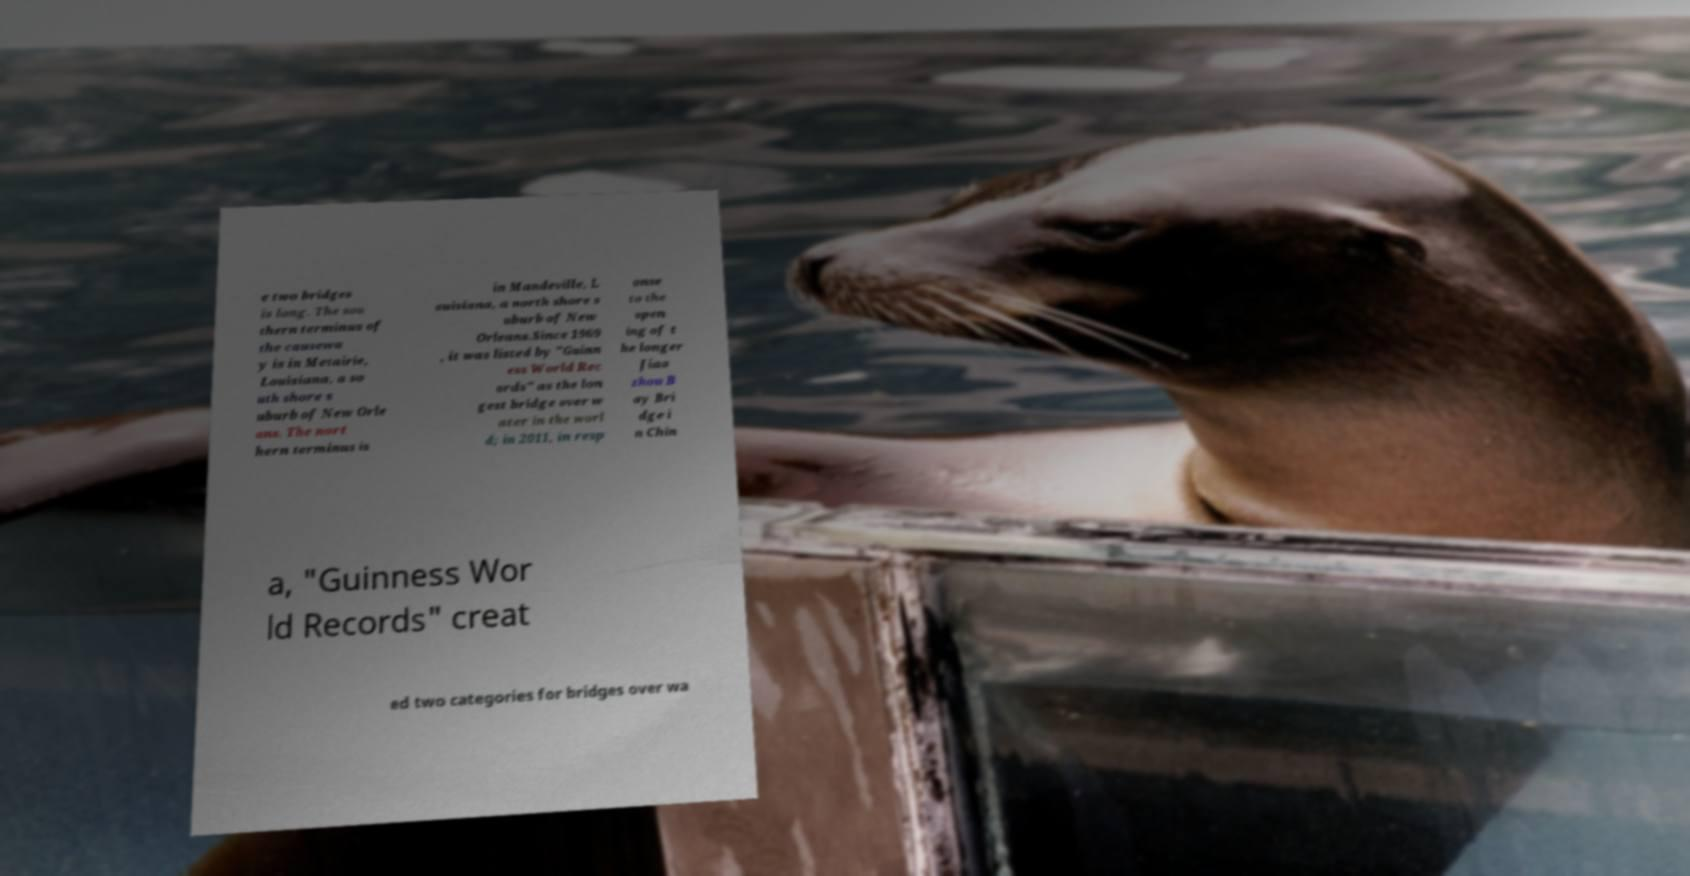What messages or text are displayed in this image? I need them in a readable, typed format. e two bridges is long. The sou thern terminus of the causewa y is in Metairie, Louisiana, a so uth shore s uburb of New Orle ans. The nort hern terminus is in Mandeville, L ouisiana, a north shore s uburb of New Orleans.Since 1969 , it was listed by "Guinn ess World Rec ords" as the lon gest bridge over w ater in the worl d; in 2011, in resp onse to the open ing of t he longer Jiao zhou B ay Bri dge i n Chin a, "Guinness Wor ld Records" creat ed two categories for bridges over wa 